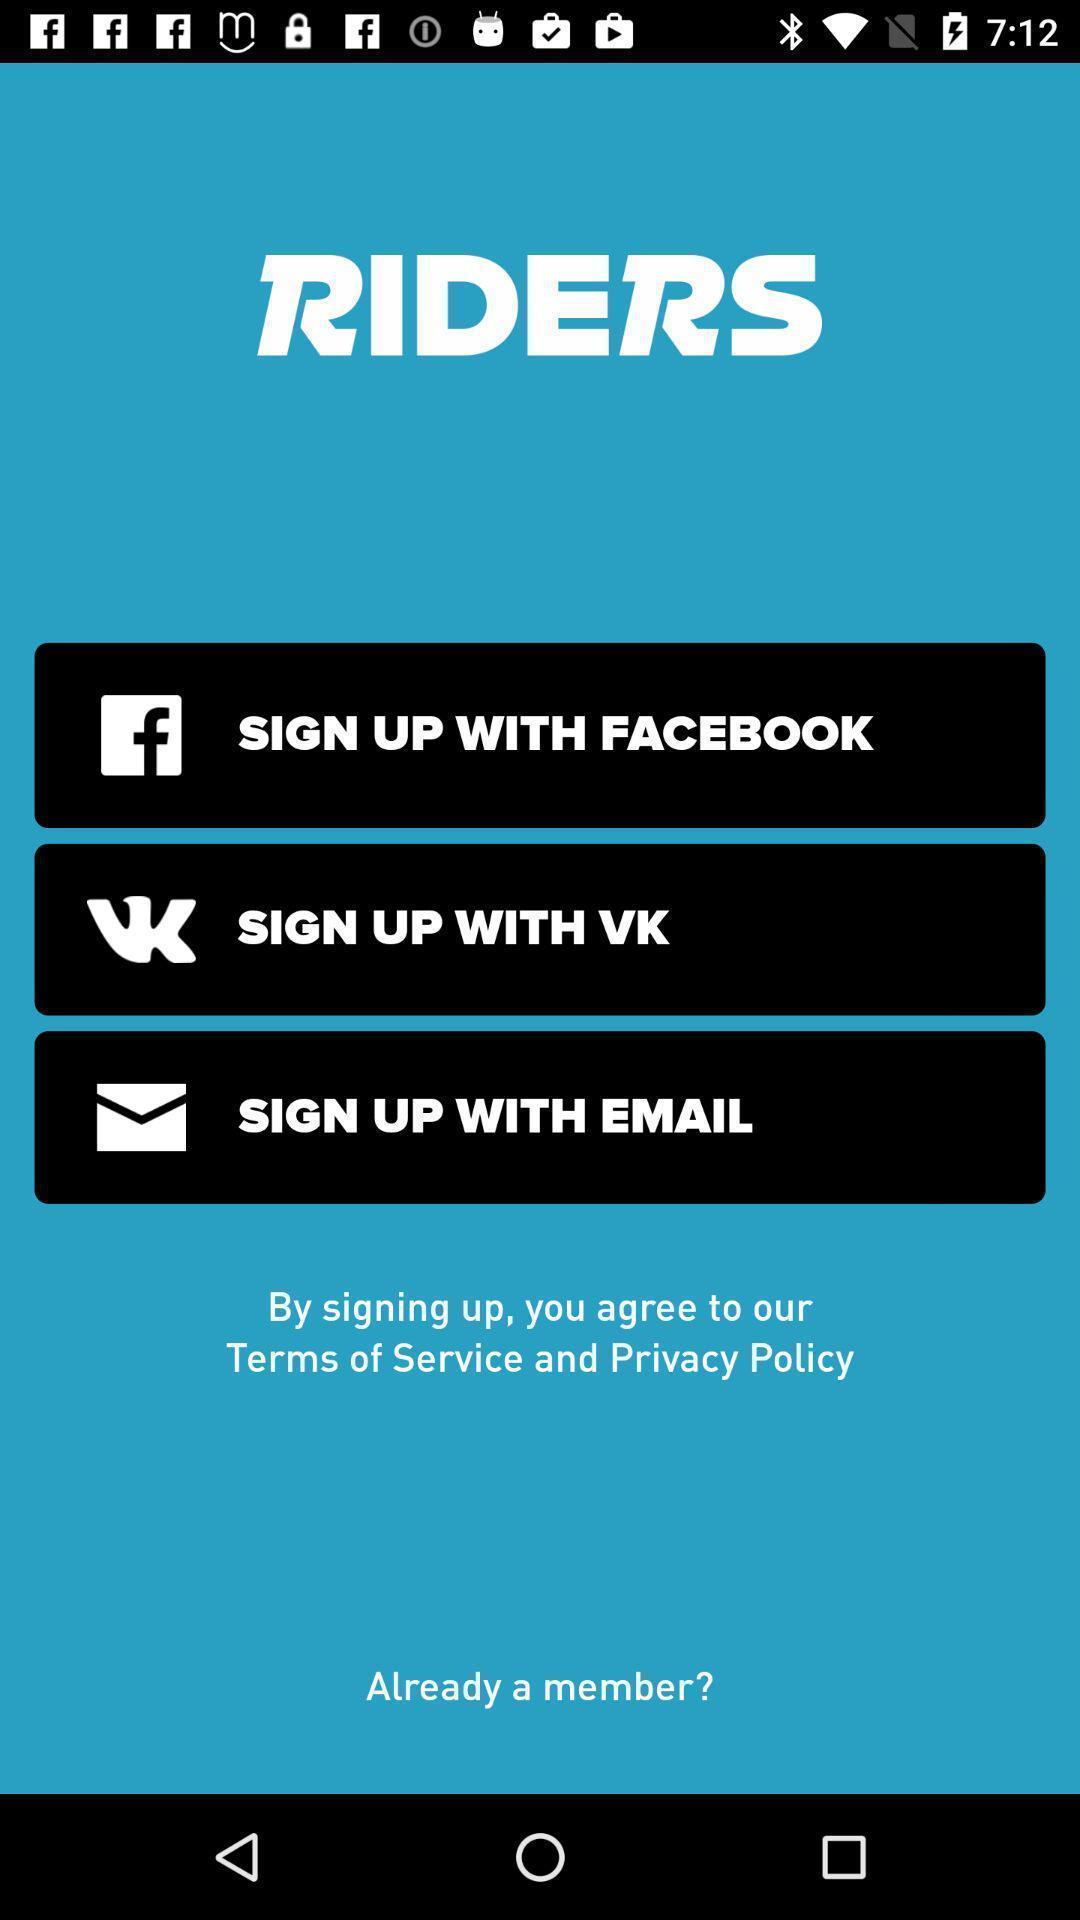Describe this image in words. Sign up with different applications displayed. 